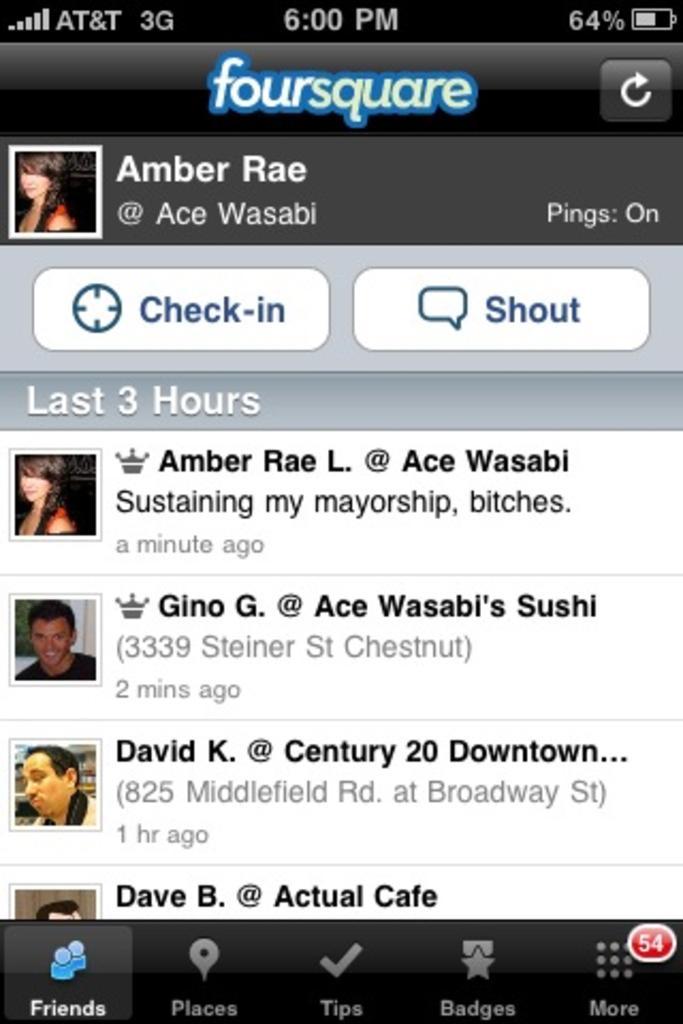Could you give a brief overview of what you see in this image? In this image there is a screenshot, on the screenshot there is a text and some persons. 